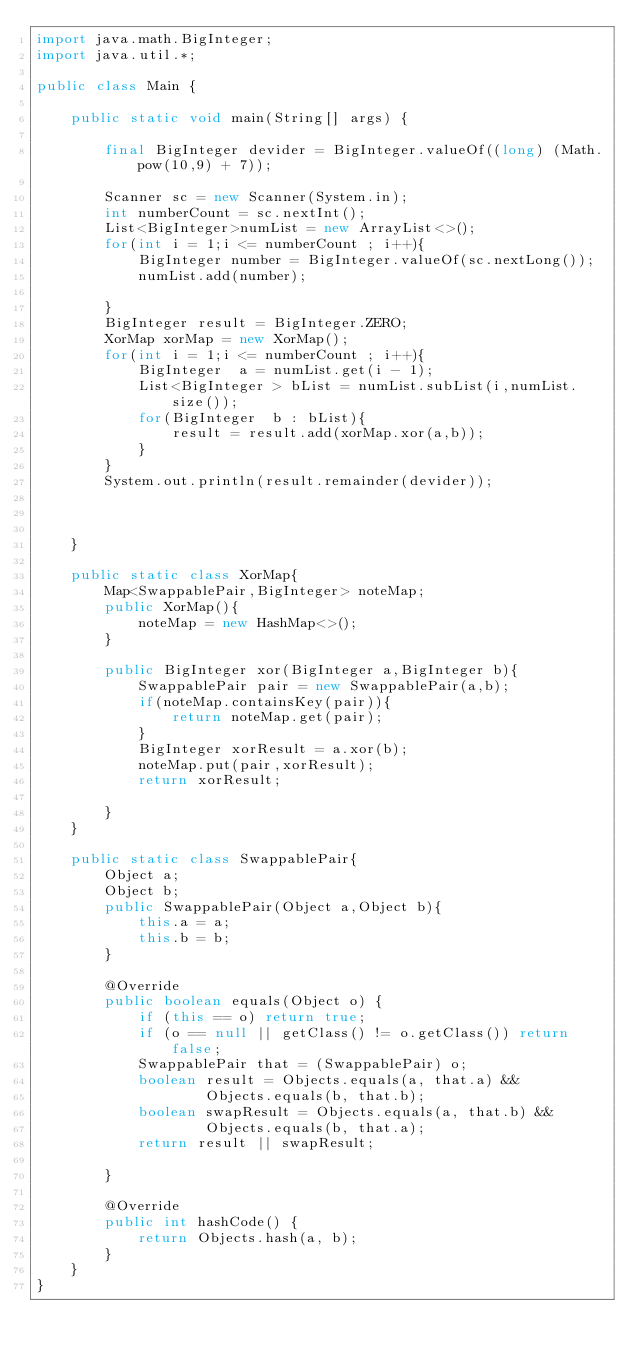Convert code to text. <code><loc_0><loc_0><loc_500><loc_500><_Java_>import java.math.BigInteger;
import java.util.*;

public class Main {

    public static void main(String[] args) {

        final BigInteger devider = BigInteger.valueOf((long) (Math.pow(10,9) + 7));

        Scanner sc = new Scanner(System.in);
        int numberCount = sc.nextInt();
        List<BigInteger>numList = new ArrayList<>();
        for(int i = 1;i <= numberCount ; i++){
            BigInteger number = BigInteger.valueOf(sc.nextLong());
            numList.add(number);

        }
        BigInteger result = BigInteger.ZERO;
        XorMap xorMap = new XorMap();
        for(int i = 1;i <= numberCount ; i++){
            BigInteger  a = numList.get(i - 1);
            List<BigInteger > bList = numList.subList(i,numList.size());
            for(BigInteger  b : bList){
                result = result.add(xorMap.xor(a,b));
            }
        }
        System.out.println(result.remainder(devider));



    }

    public static class XorMap{
        Map<SwappablePair,BigInteger> noteMap;
        public XorMap(){
            noteMap = new HashMap<>();
        }

        public BigInteger xor(BigInteger a,BigInteger b){
            SwappablePair pair = new SwappablePair(a,b);
            if(noteMap.containsKey(pair)){
                return noteMap.get(pair);
            }
            BigInteger xorResult = a.xor(b);
            noteMap.put(pair,xorResult);
            return xorResult;

        }
    }

    public static class SwappablePair{
        Object a;
        Object b;
        public SwappablePair(Object a,Object b){
            this.a = a;
            this.b = b;
        }

        @Override
        public boolean equals(Object o) {
            if (this == o) return true;
            if (o == null || getClass() != o.getClass()) return false;
            SwappablePair that = (SwappablePair) o;
            boolean result = Objects.equals(a, that.a) &&
                    Objects.equals(b, that.b);
            boolean swapResult = Objects.equals(a, that.b) &&
                    Objects.equals(b, that.a);
            return result || swapResult;

        }

        @Override
        public int hashCode() {
            return Objects.hash(a, b);
        }
    }
}
</code> 